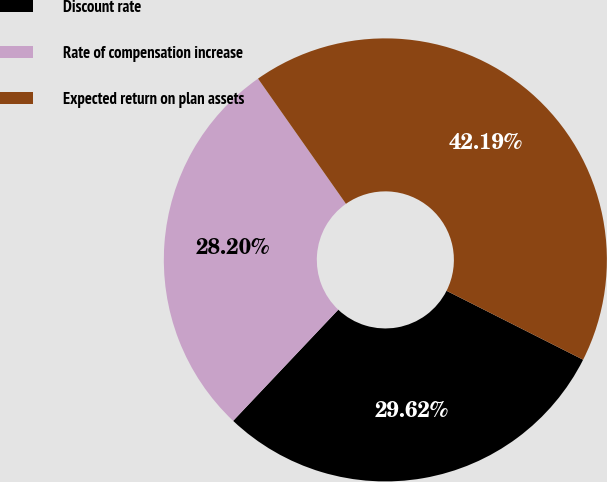<chart> <loc_0><loc_0><loc_500><loc_500><pie_chart><fcel>Discount rate<fcel>Rate of compensation increase<fcel>Expected return on plan assets<nl><fcel>29.62%<fcel>28.2%<fcel>42.19%<nl></chart> 